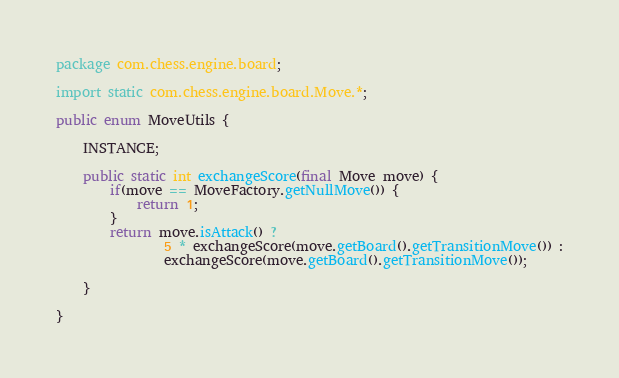Convert code to text. <code><loc_0><loc_0><loc_500><loc_500><_Java_>package com.chess.engine.board;

import static com.chess.engine.board.Move.*;

public enum MoveUtils {

    INSTANCE;

    public static int exchangeScore(final Move move) {
        if(move == MoveFactory.getNullMove()) {
            return 1;
        }
        return move.isAttack() ?
                5 * exchangeScore(move.getBoard().getTransitionMove()) :
                exchangeScore(move.getBoard().getTransitionMove());

    }

}</code> 